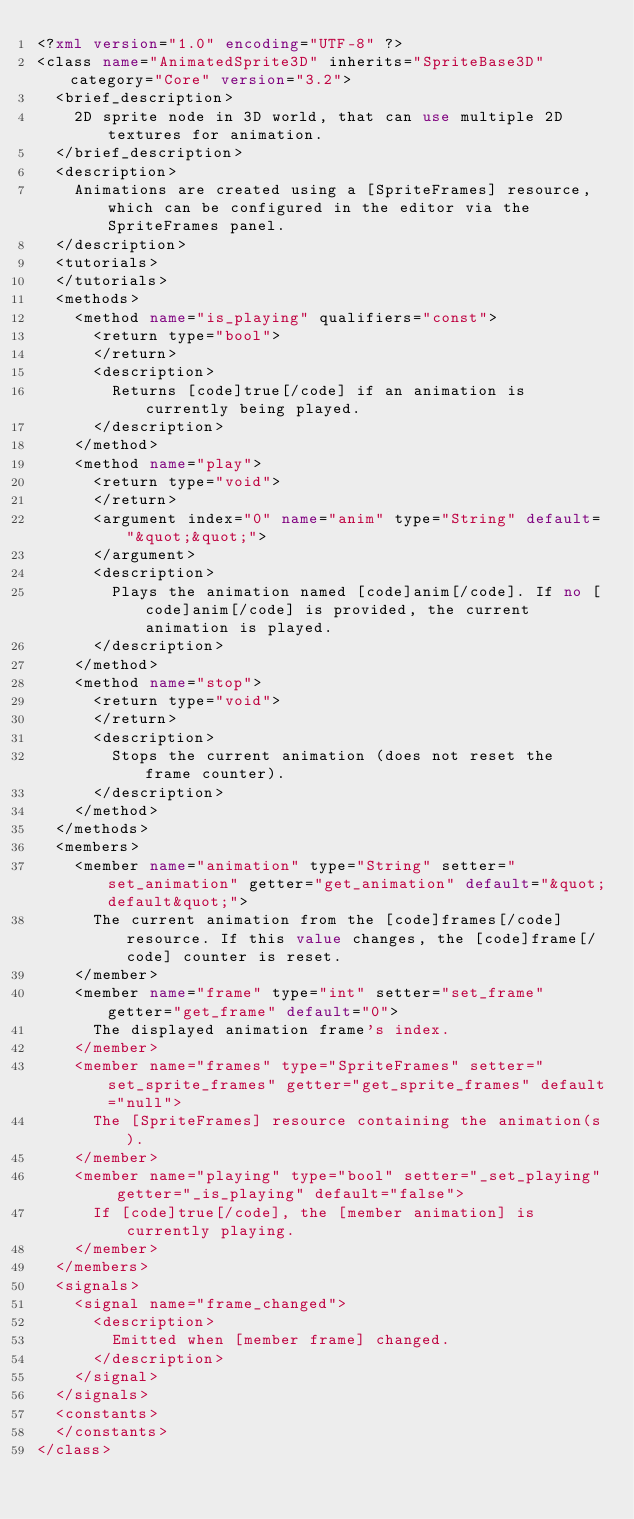<code> <loc_0><loc_0><loc_500><loc_500><_XML_><?xml version="1.0" encoding="UTF-8" ?>
<class name="AnimatedSprite3D" inherits="SpriteBase3D" category="Core" version="3.2">
	<brief_description>
		2D sprite node in 3D world, that can use multiple 2D textures for animation.
	</brief_description>
	<description>
		Animations are created using a [SpriteFrames] resource, which can be configured in the editor via the SpriteFrames panel.
	</description>
	<tutorials>
	</tutorials>
	<methods>
		<method name="is_playing" qualifiers="const">
			<return type="bool">
			</return>
			<description>
				Returns [code]true[/code] if an animation is currently being played.
			</description>
		</method>
		<method name="play">
			<return type="void">
			</return>
			<argument index="0" name="anim" type="String" default="&quot;&quot;">
			</argument>
			<description>
				Plays the animation named [code]anim[/code]. If no [code]anim[/code] is provided, the current animation is played.
			</description>
		</method>
		<method name="stop">
			<return type="void">
			</return>
			<description>
				Stops the current animation (does not reset the frame counter).
			</description>
		</method>
	</methods>
	<members>
		<member name="animation" type="String" setter="set_animation" getter="get_animation" default="&quot;default&quot;">
			The current animation from the [code]frames[/code] resource. If this value changes, the [code]frame[/code] counter is reset.
		</member>
		<member name="frame" type="int" setter="set_frame" getter="get_frame" default="0">
			The displayed animation frame's index.
		</member>
		<member name="frames" type="SpriteFrames" setter="set_sprite_frames" getter="get_sprite_frames" default="null">
			The [SpriteFrames] resource containing the animation(s).
		</member>
		<member name="playing" type="bool" setter="_set_playing" getter="_is_playing" default="false">
			If [code]true[/code], the [member animation] is currently playing.
		</member>
	</members>
	<signals>
		<signal name="frame_changed">
			<description>
				Emitted when [member frame] changed.
			</description>
		</signal>
	</signals>
	<constants>
	</constants>
</class>
</code> 